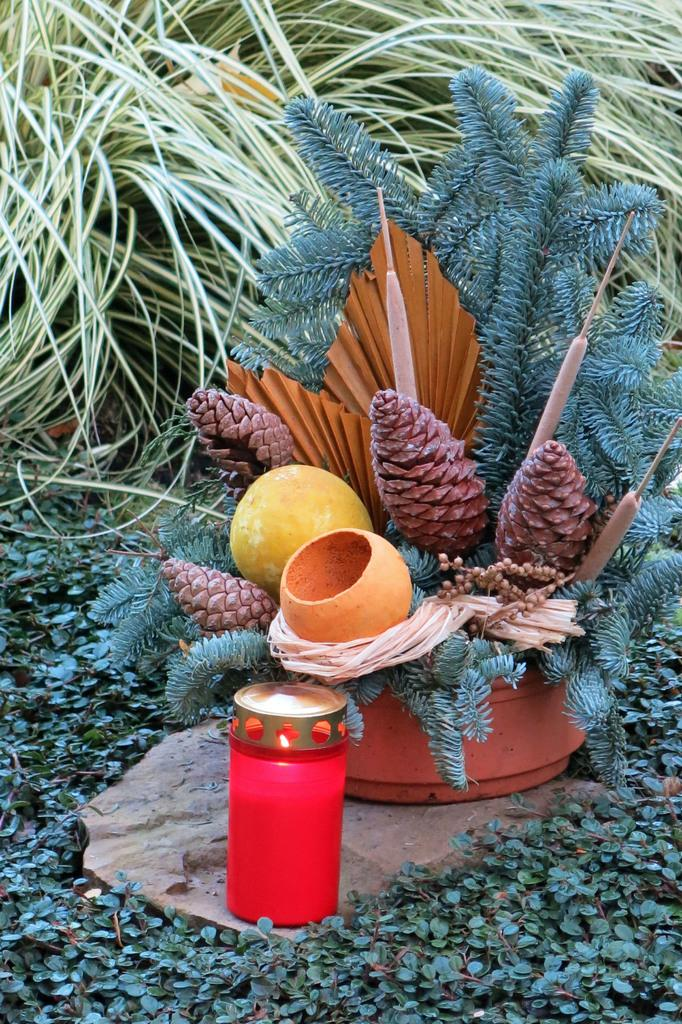What is in the image contains artificial plants? There is a pot with artificial plants in the image. What is the color of the bottle in the image? There is a pink bottle in the image. What type of plants are on the ground in the image? There are small plants on the ground in the image. How does the cart help the plants grow in the image? There is no cart present in the image, so it cannot help the plants grow. 